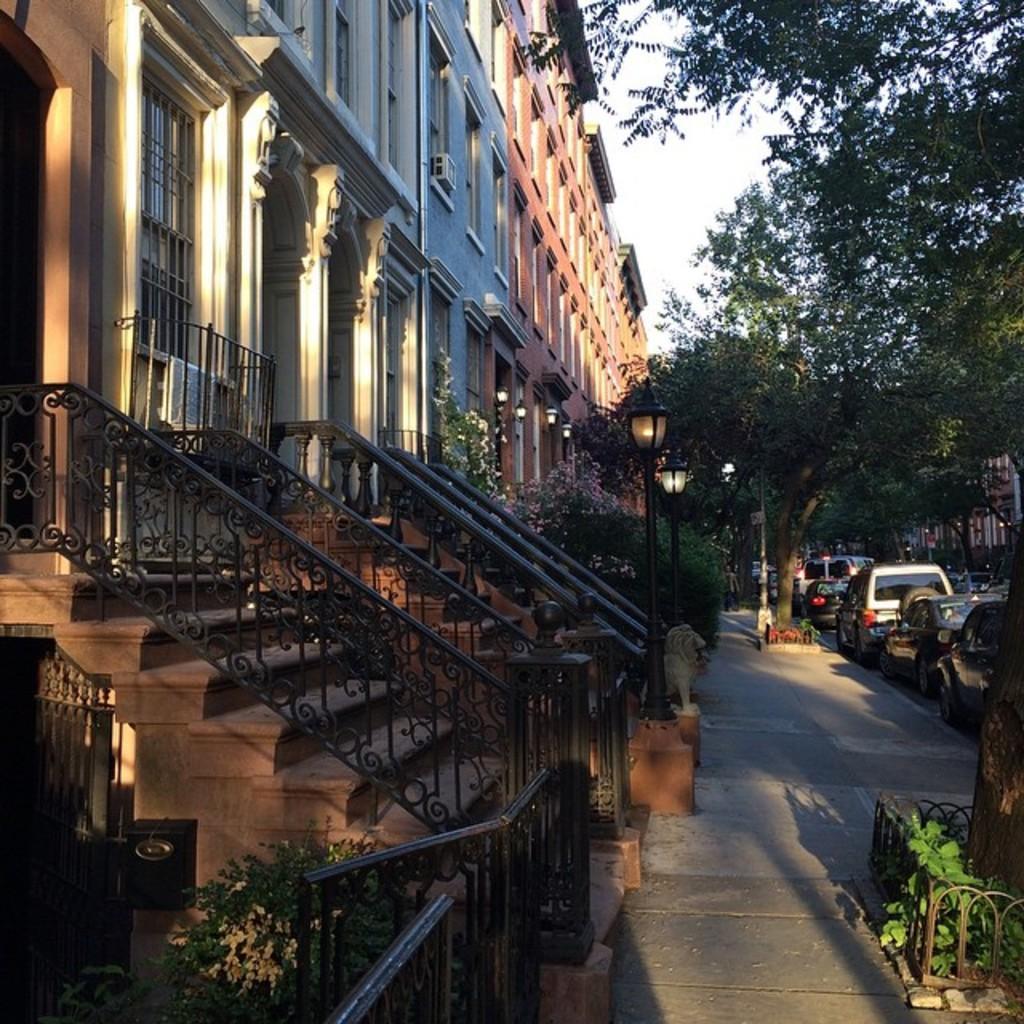In one or two sentences, can you explain what this image depicts? In this picture, there is a building with windows and hand grills towards the left. Before it, there is a footpath. Towards the right, there is a road. On the road, there are vehicles. On the top right, there are trees. At the bottom, there are plants. 